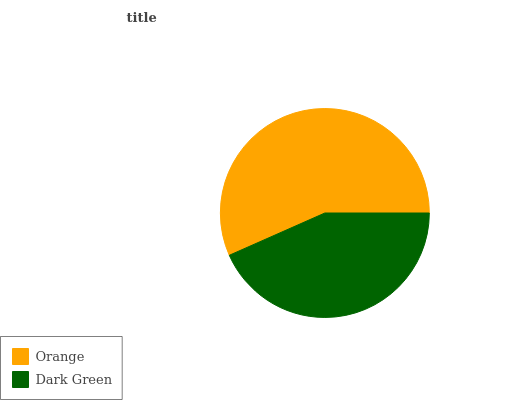Is Dark Green the minimum?
Answer yes or no. Yes. Is Orange the maximum?
Answer yes or no. Yes. Is Dark Green the maximum?
Answer yes or no. No. Is Orange greater than Dark Green?
Answer yes or no. Yes. Is Dark Green less than Orange?
Answer yes or no. Yes. Is Dark Green greater than Orange?
Answer yes or no. No. Is Orange less than Dark Green?
Answer yes or no. No. Is Orange the high median?
Answer yes or no. Yes. Is Dark Green the low median?
Answer yes or no. Yes. Is Dark Green the high median?
Answer yes or no. No. Is Orange the low median?
Answer yes or no. No. 